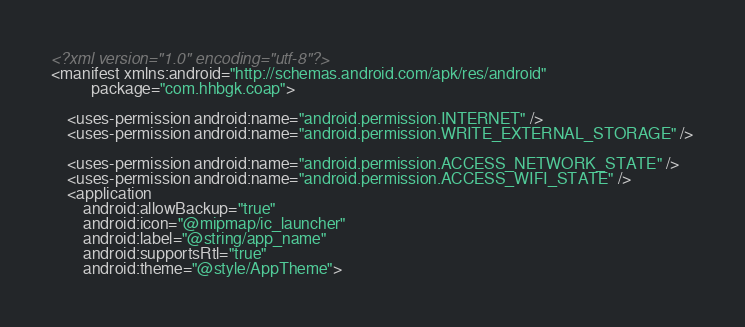<code> <loc_0><loc_0><loc_500><loc_500><_XML_><?xml version="1.0" encoding="utf-8"?>
<manifest xmlns:android="http://schemas.android.com/apk/res/android"
          package="com.hhbgk.coap">

    <uses-permission android:name="android.permission.INTERNET" />
    <uses-permission android:name="android.permission.WRITE_EXTERNAL_STORAGE" />

    <uses-permission android:name="android.permission.ACCESS_NETWORK_STATE" />
    <uses-permission android:name="android.permission.ACCESS_WIFI_STATE" />
    <application
        android:allowBackup="true"
        android:icon="@mipmap/ic_launcher"
        android:label="@string/app_name"
        android:supportsRtl="true"
        android:theme="@style/AppTheme"></code> 